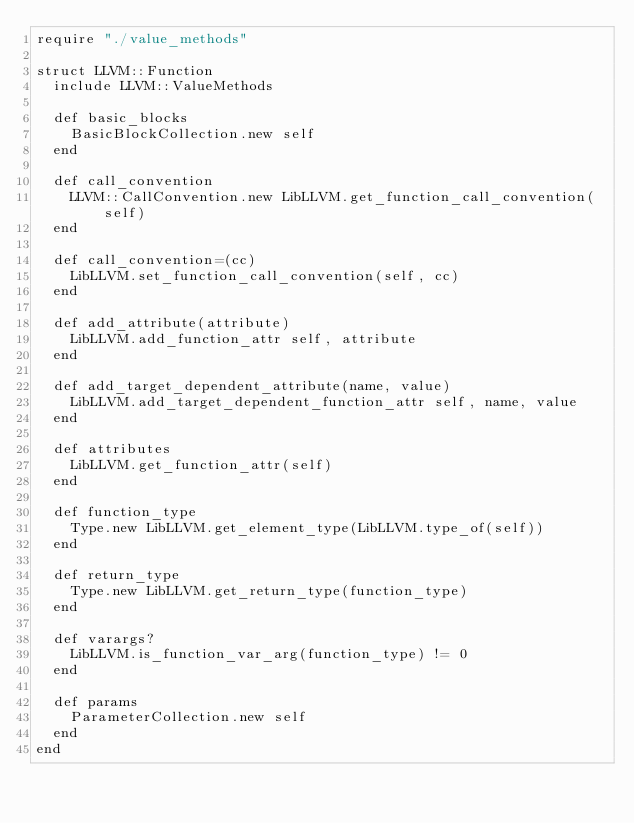Convert code to text. <code><loc_0><loc_0><loc_500><loc_500><_Crystal_>require "./value_methods"

struct LLVM::Function
  include LLVM::ValueMethods

  def basic_blocks
    BasicBlockCollection.new self
  end

  def call_convention
    LLVM::CallConvention.new LibLLVM.get_function_call_convention(self)
  end

  def call_convention=(cc)
    LibLLVM.set_function_call_convention(self, cc)
  end

  def add_attribute(attribute)
    LibLLVM.add_function_attr self, attribute
  end

  def add_target_dependent_attribute(name, value)
    LibLLVM.add_target_dependent_function_attr self, name, value
  end

  def attributes
    LibLLVM.get_function_attr(self)
  end

  def function_type
    Type.new LibLLVM.get_element_type(LibLLVM.type_of(self))
  end

  def return_type
    Type.new LibLLVM.get_return_type(function_type)
  end

  def varargs?
    LibLLVM.is_function_var_arg(function_type) != 0
  end

  def params
    ParameterCollection.new self
  end
end
</code> 